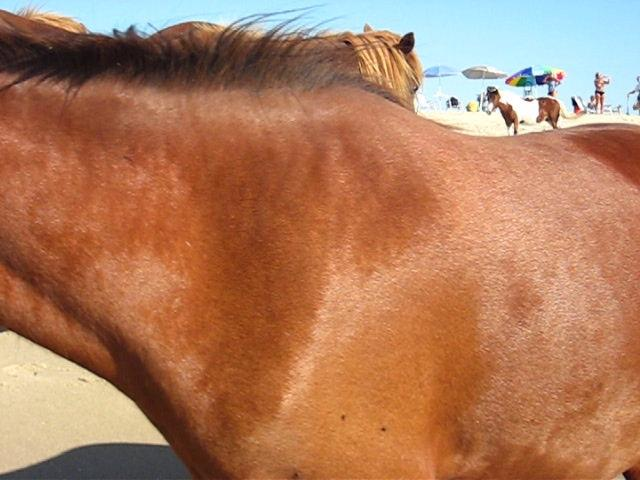What type flag elements appear in a pictured umbrella? Please explain your reasoning. gay rainbow. The umbrella has the entire color spectrum. this color scheme is associated with pride. 